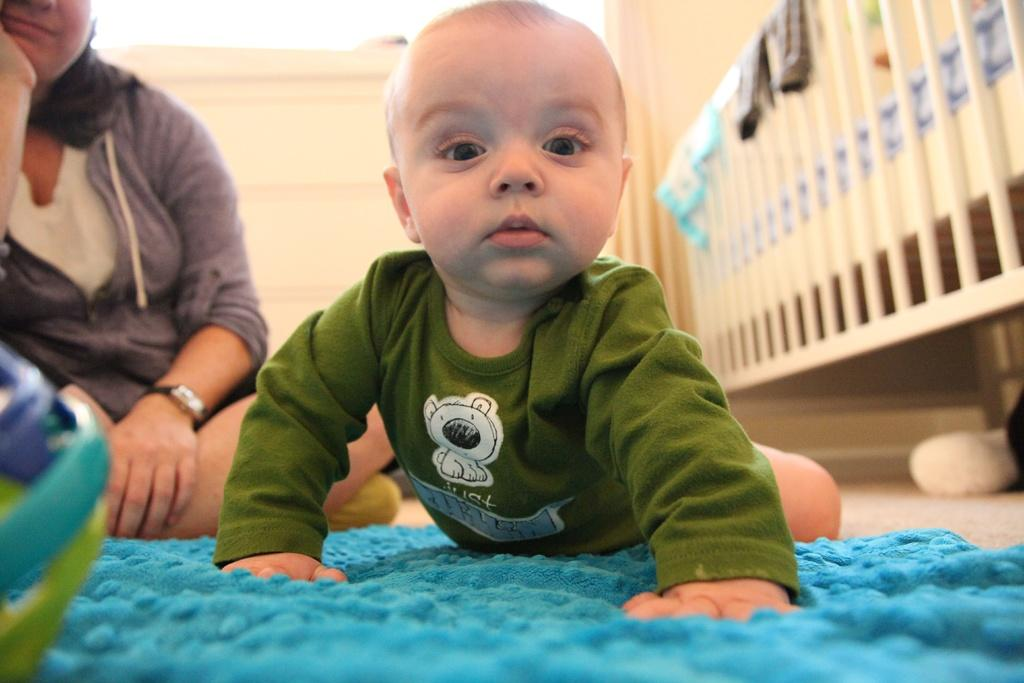What is the boy doing in the image? The boy is on a mat in the image. Where is the mat located? The mat is on the floor. Who else is present in the image? There is a woman in the image. What can be seen in the background of the image? In the background, there are clothes on a bed. How does the boy slip into the sea in the image? There is no sea present in the image, and the boy does not slip into any body of water. 